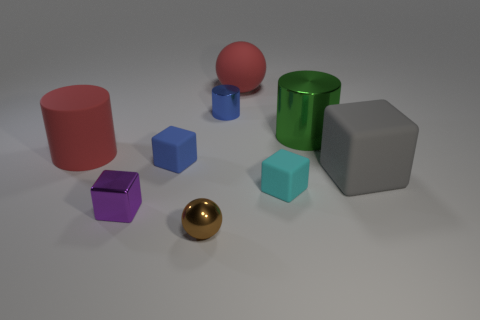Subtract 1 cylinders. How many cylinders are left? 2 Subtract all big red rubber cylinders. How many cylinders are left? 2 Add 1 gray blocks. How many objects exist? 10 Subtract all purple blocks. How many blocks are left? 3 Subtract 0 yellow balls. How many objects are left? 9 Subtract all cylinders. How many objects are left? 6 Subtract all yellow spheres. Subtract all cyan blocks. How many spheres are left? 2 Subtract all green balls. How many cyan blocks are left? 1 Subtract all small matte things. Subtract all small purple metal blocks. How many objects are left? 6 Add 7 red rubber objects. How many red rubber objects are left? 9 